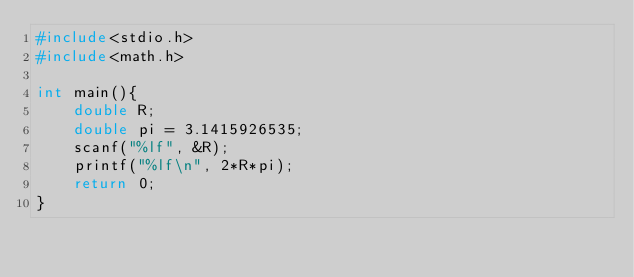Convert code to text. <code><loc_0><loc_0><loc_500><loc_500><_C_>#include<stdio.h>
#include<math.h>

int main(){
	double R;
	double pi = 3.1415926535;
	scanf("%lf", &R);
	printf("%lf\n", 2*R*pi);
	return 0;
}</code> 